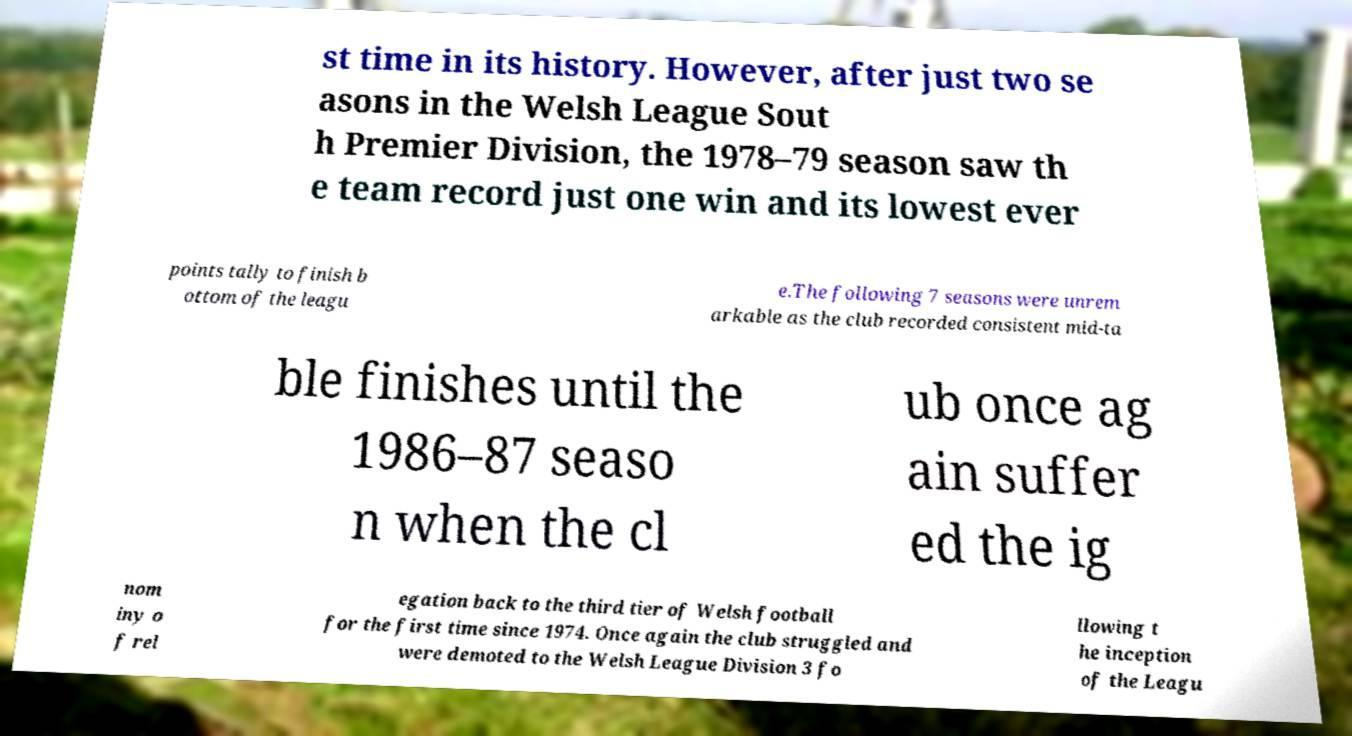Can you read and provide the text displayed in the image?This photo seems to have some interesting text. Can you extract and type it out for me? st time in its history. However, after just two se asons in the Welsh League Sout h Premier Division, the 1978–79 season saw th e team record just one win and its lowest ever points tally to finish b ottom of the leagu e.The following 7 seasons were unrem arkable as the club recorded consistent mid-ta ble finishes until the 1986–87 seaso n when the cl ub once ag ain suffer ed the ig nom iny o f rel egation back to the third tier of Welsh football for the first time since 1974. Once again the club struggled and were demoted to the Welsh League Division 3 fo llowing t he inception of the Leagu 